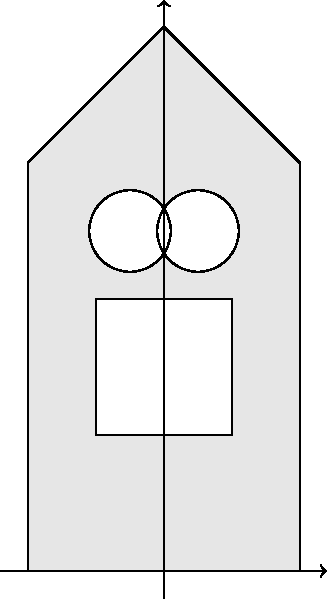In the coat of arms design shown above, which type of symmetry is exhibited by the overall shield shape and its internal elements? To determine the type of symmetry in this coat of arms design, let's analyze the shield shape and its internal elements step by step:

1. Shield shape: The shield is symmetrical about a vertical line passing through its center.

2. Cross: The white cross in the center is also symmetrical about the vertical line passing through the center of the shield.

3. Circles: There are two white circles of equal size, placed symmetrically on either side of the vertical center line.

4. Overall composition: All elements maintain their positions and shapes when reflected across the vertical center line.

5. Horizontal symmetry: The design does not exhibit symmetry across a horizontal line.

6. Rotational symmetry: The design does not have rotational symmetry of any order other than 360°.

Given these observations, we can conclude that the coat of arms design exhibits reflectional symmetry (also known as line symmetry or mirror symmetry) about a vertical line passing through its center. This type of symmetry is characterized by the property that one half of the figure is the mirror image of the other half.

In geometric terms, this is referred to as bilateral symmetry or reflection symmetry across a vertical axis.
Answer: Bilateral (vertical reflection) symmetry 